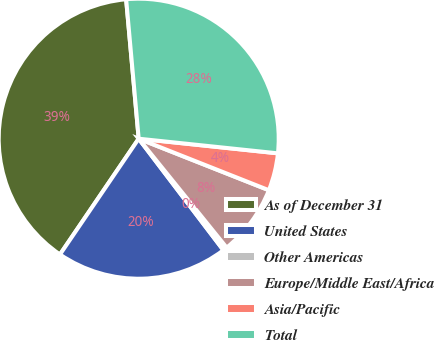Convert chart to OTSL. <chart><loc_0><loc_0><loc_500><loc_500><pie_chart><fcel>As of December 31<fcel>United States<fcel>Other Americas<fcel>Europe/Middle East/Africa<fcel>Asia/Pacific<fcel>Total<nl><fcel>39.07%<fcel>19.85%<fcel>0.47%<fcel>8.19%<fcel>4.33%<fcel>28.1%<nl></chart> 